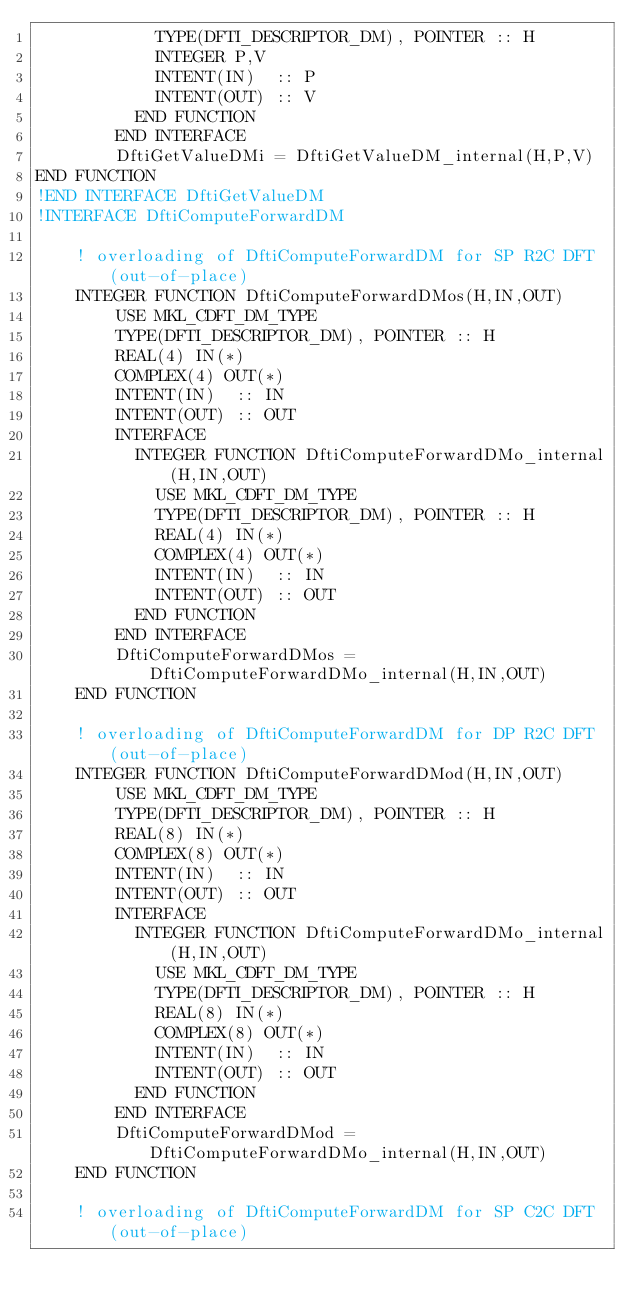Convert code to text. <code><loc_0><loc_0><loc_500><loc_500><_FORTRAN_>            TYPE(DFTI_DESCRIPTOR_DM), POINTER :: H
            INTEGER P,V
            INTENT(IN)  :: P
            INTENT(OUT) :: V
          END FUNCTION
        END INTERFACE
        DftiGetValueDMi = DftiGetValueDM_internal(H,P,V)
END FUNCTION
!END INTERFACE DftiGetValueDM
!INTERFACE DftiComputeForwardDM

    ! overloading of DftiComputeForwardDM for SP R2C DFT (out-of-place)
    INTEGER FUNCTION DftiComputeForwardDMos(H,IN,OUT)
        USE MKL_CDFT_DM_TYPE
        TYPE(DFTI_DESCRIPTOR_DM), POINTER :: H
        REAL(4) IN(*)
        COMPLEX(4) OUT(*)
        INTENT(IN)  :: IN
        INTENT(OUT) :: OUT
        INTERFACE
          INTEGER FUNCTION DftiComputeForwardDMo_internal(H,IN,OUT)
            USE MKL_CDFT_DM_TYPE
            TYPE(DFTI_DESCRIPTOR_DM), POINTER :: H
            REAL(4) IN(*)
            COMPLEX(4) OUT(*)
            INTENT(IN)  :: IN
            INTENT(OUT) :: OUT
          END FUNCTION
        END INTERFACE
        DftiComputeForwardDMos = DftiComputeForwardDMo_internal(H,IN,OUT)
    END FUNCTION

    ! overloading of DftiComputeForwardDM for DP R2C DFT (out-of-place)
    INTEGER FUNCTION DftiComputeForwardDMod(H,IN,OUT)
        USE MKL_CDFT_DM_TYPE
        TYPE(DFTI_DESCRIPTOR_DM), POINTER :: H
        REAL(8) IN(*)
        COMPLEX(8) OUT(*)
        INTENT(IN)  :: IN
        INTENT(OUT) :: OUT
        INTERFACE
          INTEGER FUNCTION DftiComputeForwardDMo_internal(H,IN,OUT)
            USE MKL_CDFT_DM_TYPE
            TYPE(DFTI_DESCRIPTOR_DM), POINTER :: H
            REAL(8) IN(*)
            COMPLEX(8) OUT(*)
            INTENT(IN)  :: IN
            INTENT(OUT) :: OUT
          END FUNCTION
        END INTERFACE
        DftiComputeForwardDMod = DftiComputeForwardDMo_internal(H,IN,OUT)
    END FUNCTION

    ! overloading of DftiComputeForwardDM for SP C2C DFT (out-of-place)</code> 